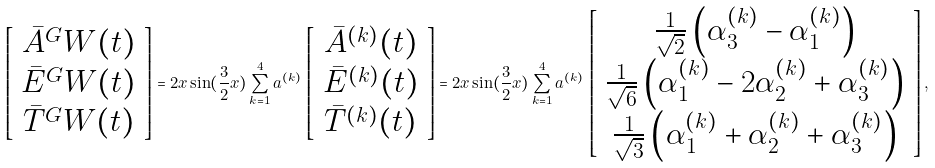Convert formula to latex. <formula><loc_0><loc_0><loc_500><loc_500>\left [ \begin{array} { c } \bar { A } ^ { G } W ( t ) \\ \bar { E } ^ { G } W ( t ) \\ \bar { T } ^ { G } W ( t ) \end{array} \right ] = 2 x \sin ( { \frac { 3 } { 2 } } x ) \sum _ { k = 1 } ^ { 4 } a ^ { ( k ) } \, \left [ \begin{array} { c } \bar { A } ^ { ( k ) } ( t ) \\ \bar { E } ^ { ( k ) } ( t ) \\ \bar { T } ^ { ( k ) } ( t ) \end{array} \right ] = 2 x \sin ( { \frac { 3 } { 2 } } x ) \sum _ { k = 1 } ^ { 4 } a ^ { ( k ) } \, \left [ \begin{array} { c } { \frac { 1 } { \sqrt { 2 } } } \left ( \alpha ^ { ( k ) } _ { 3 } - \alpha ^ { ( k ) } _ { 1 } \right ) \\ { \frac { 1 } { \sqrt { 6 } } } \left ( \alpha ^ { ( k ) } _ { 1 } - 2 \alpha ^ { ( k ) } _ { 2 } + \alpha ^ { ( k ) } _ { 3 } \right ) \\ { \frac { 1 } { \sqrt { 3 } } } \left ( \alpha ^ { ( k ) } _ { 1 } + \alpha ^ { ( k ) } _ { 2 } + \alpha ^ { ( k ) } _ { 3 } \right ) \end{array} \right ] ,</formula> 